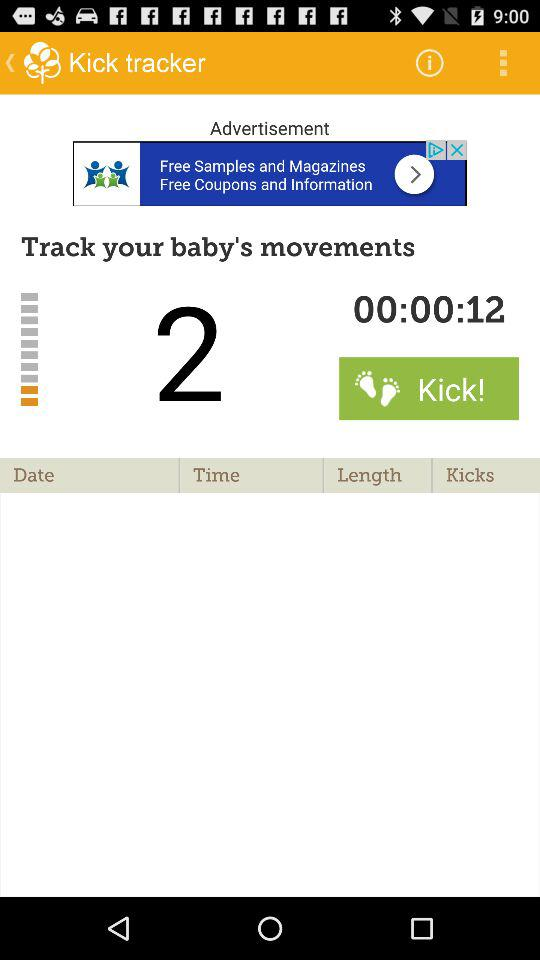What is the time duration when the "baby's movements" occur? The duration is 00:00:12. 